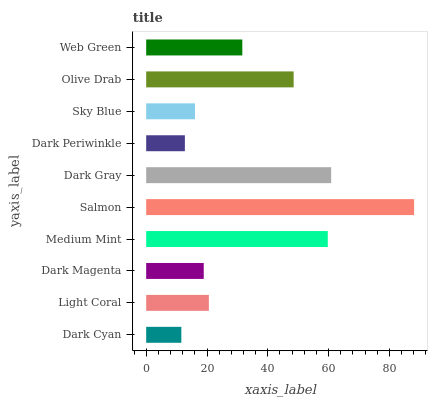Is Dark Cyan the minimum?
Answer yes or no. Yes. Is Salmon the maximum?
Answer yes or no. Yes. Is Light Coral the minimum?
Answer yes or no. No. Is Light Coral the maximum?
Answer yes or no. No. Is Light Coral greater than Dark Cyan?
Answer yes or no. Yes. Is Dark Cyan less than Light Coral?
Answer yes or no. Yes. Is Dark Cyan greater than Light Coral?
Answer yes or no. No. Is Light Coral less than Dark Cyan?
Answer yes or no. No. Is Web Green the high median?
Answer yes or no. Yes. Is Light Coral the low median?
Answer yes or no. Yes. Is Dark Periwinkle the high median?
Answer yes or no. No. Is Sky Blue the low median?
Answer yes or no. No. 